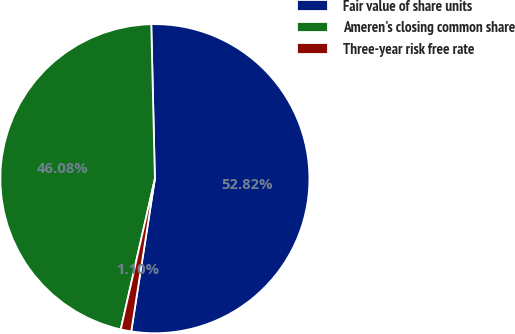Convert chart to OTSL. <chart><loc_0><loc_0><loc_500><loc_500><pie_chart><fcel>Fair value of share units<fcel>Ameren's closing common share<fcel>Three-year risk free rate<nl><fcel>52.82%<fcel>46.08%<fcel>1.1%<nl></chart> 